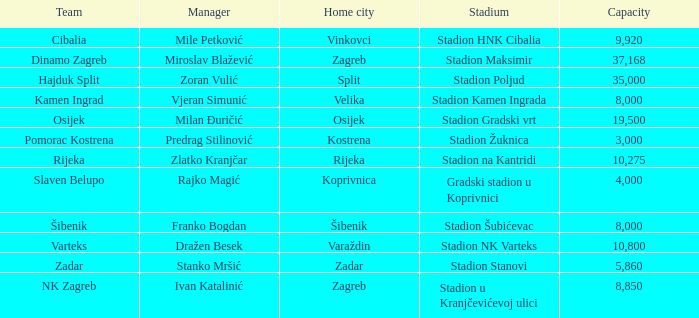What is the stadium of the NK Zagreb? Stadion u Kranjčevićevoj ulici. 